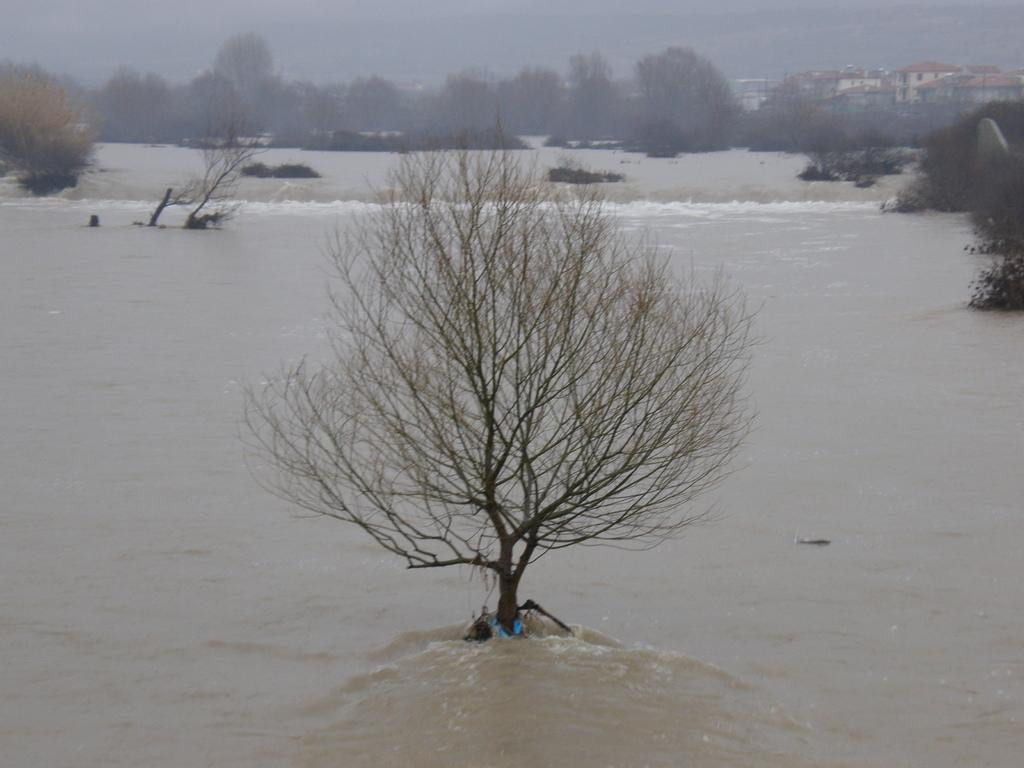What is visible in the image? Water and trees are visible in the image. What type of structures can be seen in the distance? There are houses in the distance. What type of hill can be seen in the image? There is no hill present in the image. What color is the copper toothbrush in the image? There is no toothbrush, let alone a copper one, present in the image. 